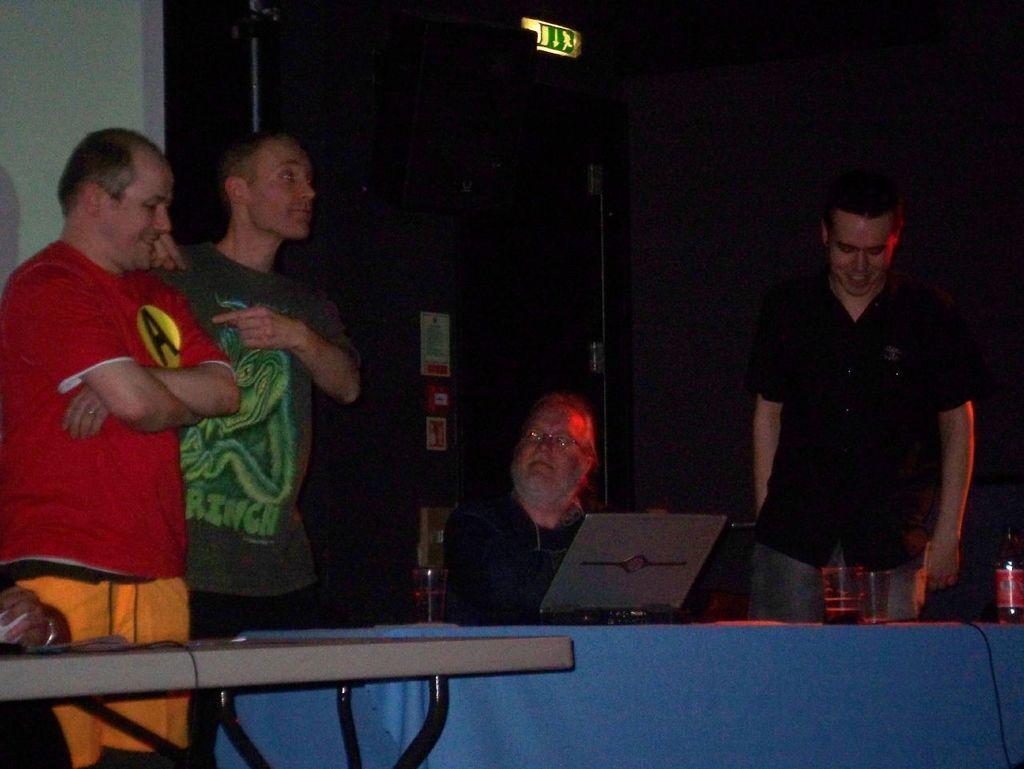Describe this image in one or two sentences. In this image we can see these three persons are standing and this man is sitting in front of the table. There is a laptop, glass and a bottle on the table. 